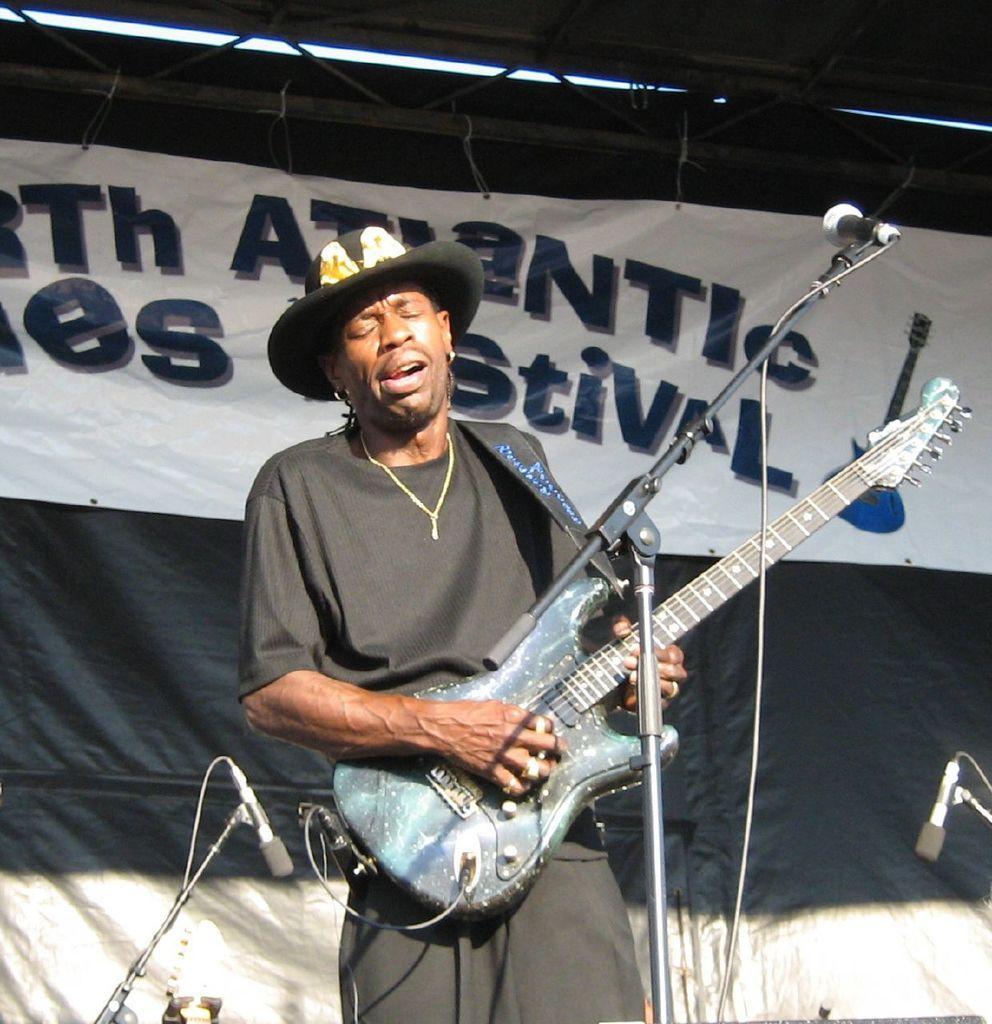How would you summarize this image in a sentence or two? In this image I see a man who is holding a guitar and he is in front of a mic, In the background another 2 mics and the banner. 